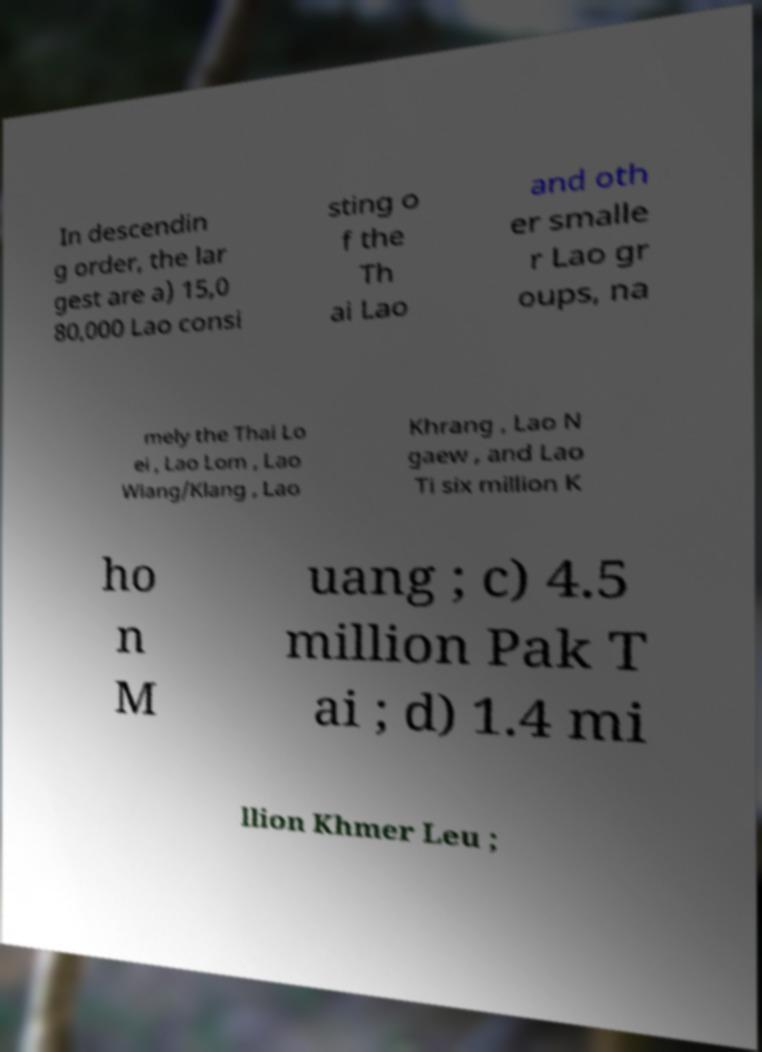Could you assist in decoding the text presented in this image and type it out clearly? In descendin g order, the lar gest are a) 15,0 80,000 Lao consi sting o f the Th ai Lao and oth er smalle r Lao gr oups, na mely the Thai Lo ei , Lao Lom , Lao Wiang/Klang , Lao Khrang , Lao N gaew , and Lao Ti six million K ho n M uang ; c) 4.5 million Pak T ai ; d) 1.4 mi llion Khmer Leu ; 